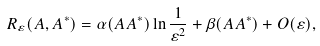Convert formula to latex. <formula><loc_0><loc_0><loc_500><loc_500>R _ { \varepsilon } ( A , A ^ { * } ) = \alpha ( A A ^ { * } ) \ln \frac { 1 } { \varepsilon ^ { 2 } } + \beta ( A A ^ { * } ) + O ( \varepsilon ) ,</formula> 